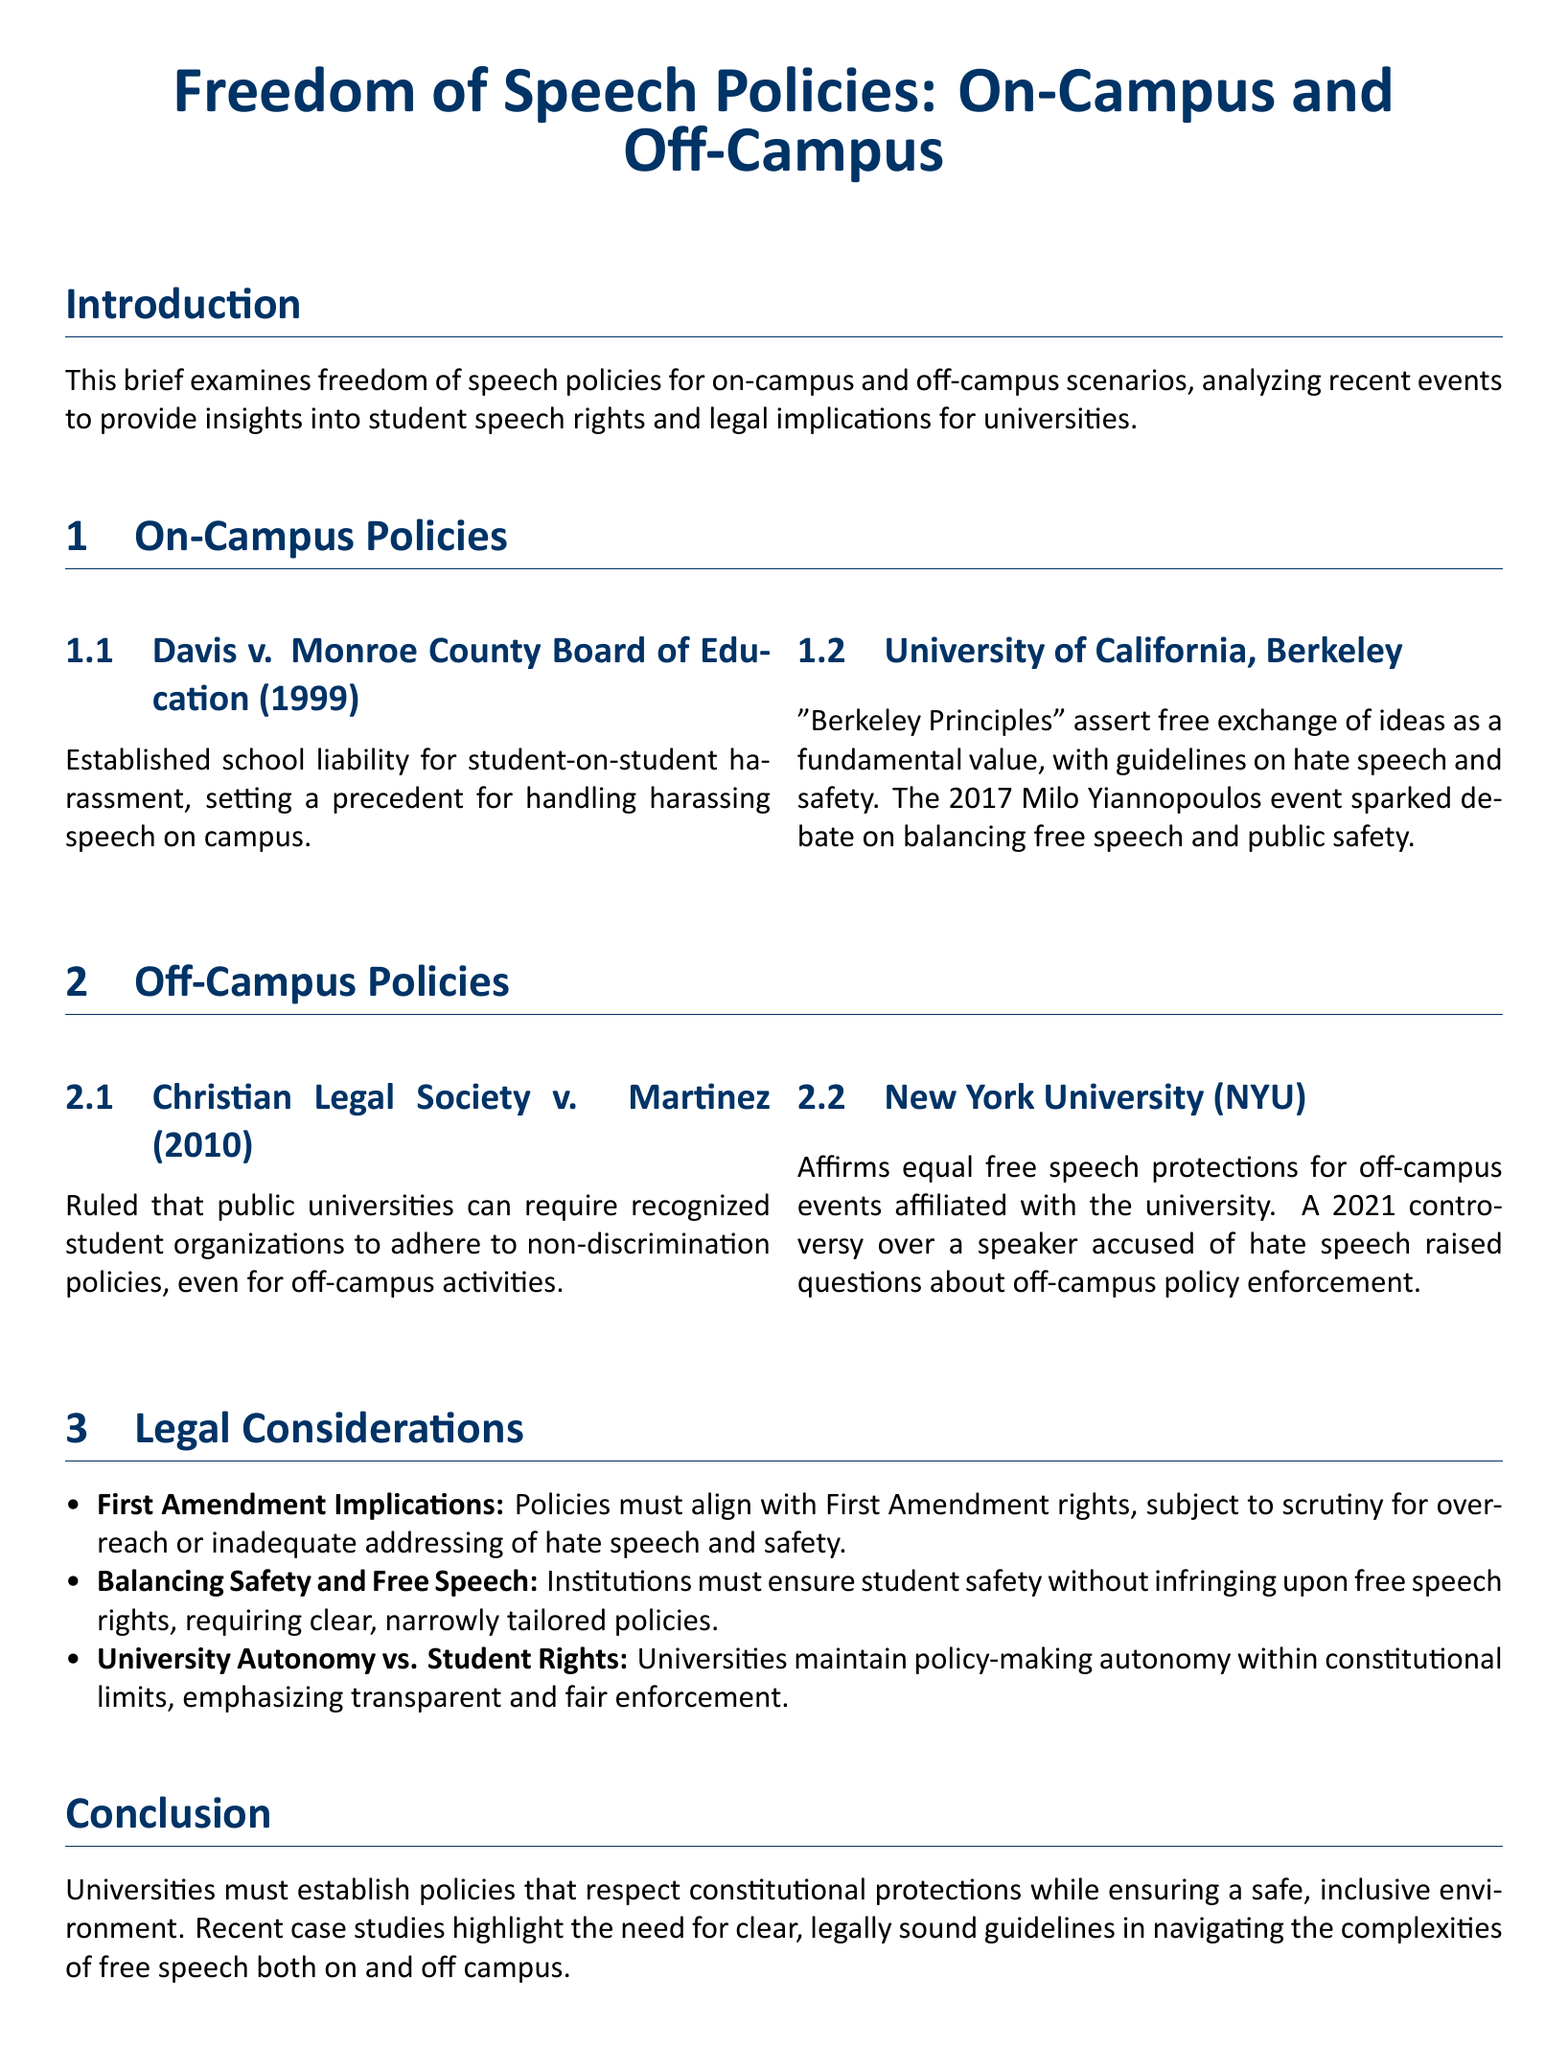What case established school liability for student-on-student harassment? The case that established this liability is Davis v. Monroe County Board of Education (1999).
Answer: Davis v. Monroe County Board of Education (1999) What university's principles assert the free exchange of ideas as a fundamental value? The University of California, Berkeley claims that free exchange of ideas is a fundamental value through its "Berkeley Principles."
Answer: University of California, Berkeley What event in 2017 sparked debate on balancing free speech and public safety at UC Berkeley? The event that sparked this debate was the Milo Yiannopoulos event.
Answer: Milo Yiannopoulos event What was the ruling in Christian Legal Society v. Martinez (2010)? The ruling stated that public universities can require organizations to adhere to non-discrimination policies for off-campus activities.
Answer: Public universities can require non-discrimination adherence What year did the controversy over a speaker accused of hate speech occur at NYU? The controversy over the speaker occurred in 2021.
Answer: 2021 What legal aspect must policies align with according to the document? Policies must align with First Amendment rights.
Answer: First Amendment rights What two aspects must institutions balance according to the legal considerations? Institutions must balance safety and free speech.
Answer: Safety and free speech In what section does the conclusion appear in the document? The conclusion appears in the Conclusion section.
Answer: Conclusion What is emphasized regarding university policy-making autonomy? The document emphasizes that it is within constitutional limits.
Answer: Within constitutional limits 